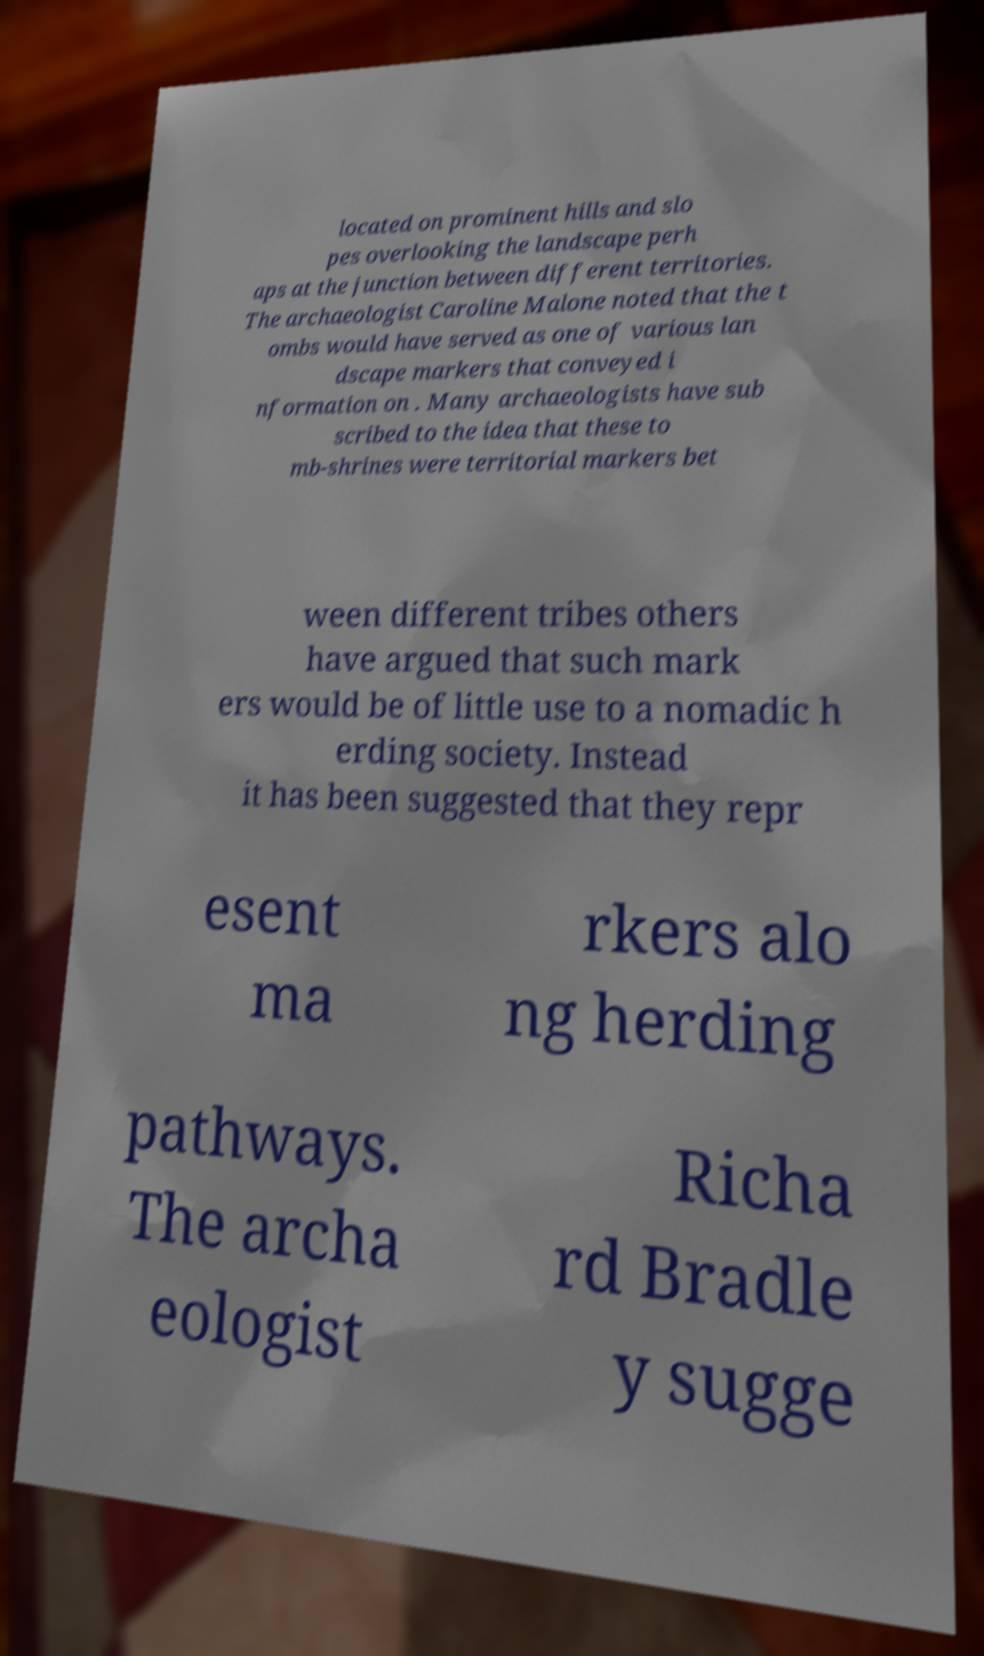What messages or text are displayed in this image? I need them in a readable, typed format. located on prominent hills and slo pes overlooking the landscape perh aps at the junction between different territories. The archaeologist Caroline Malone noted that the t ombs would have served as one of various lan dscape markers that conveyed i nformation on . Many archaeologists have sub scribed to the idea that these to mb-shrines were territorial markers bet ween different tribes others have argued that such mark ers would be of little use to a nomadic h erding society. Instead it has been suggested that they repr esent ma rkers alo ng herding pathways. The archa eologist Richa rd Bradle y sugge 